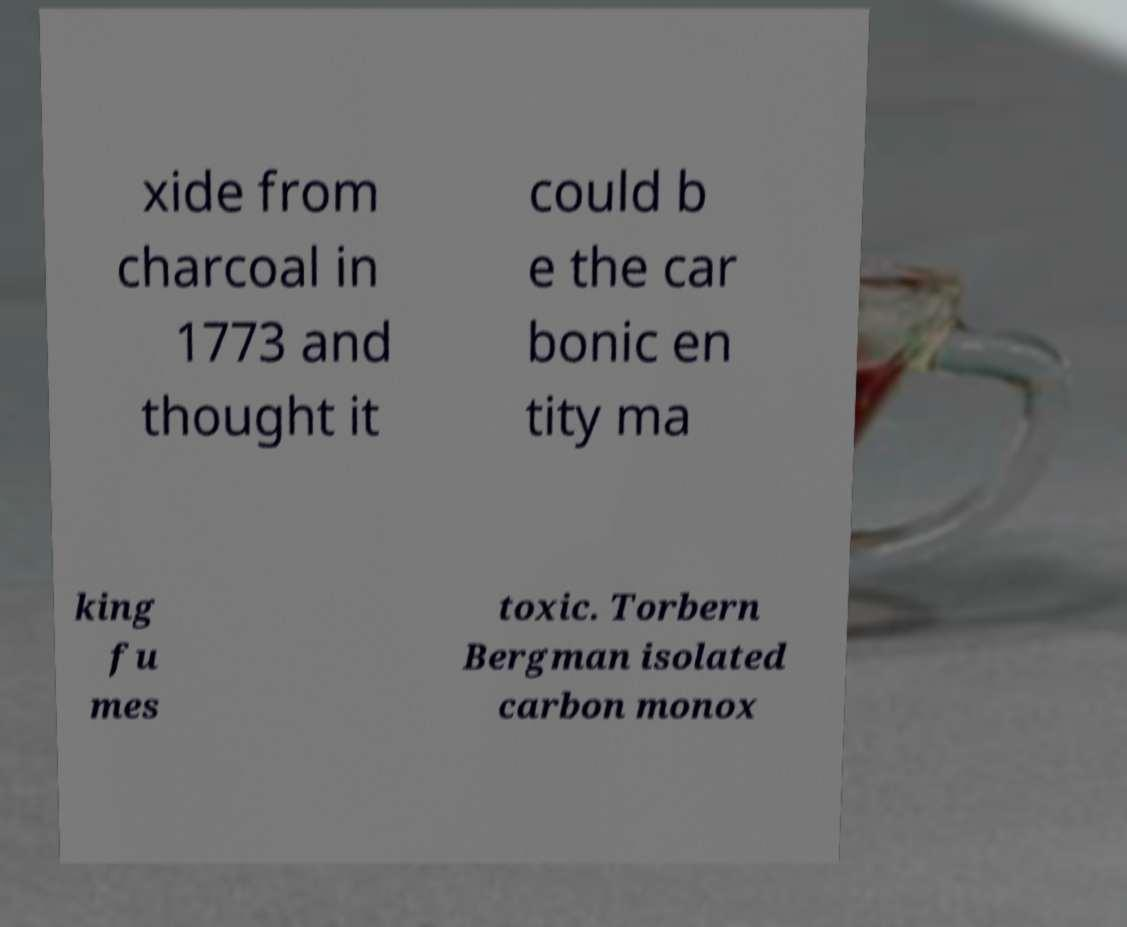There's text embedded in this image that I need extracted. Can you transcribe it verbatim? xide from charcoal in 1773 and thought it could b e the car bonic en tity ma king fu mes toxic. Torbern Bergman isolated carbon monox 